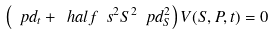Convert formula to latex. <formula><loc_0><loc_0><loc_500><loc_500>\left ( \ p d _ { t } + \ h a l f \ s ^ { 2 } S ^ { 2 } \ p d _ { S } ^ { 2 } \right ) V ( S , P , t ) = 0</formula> 